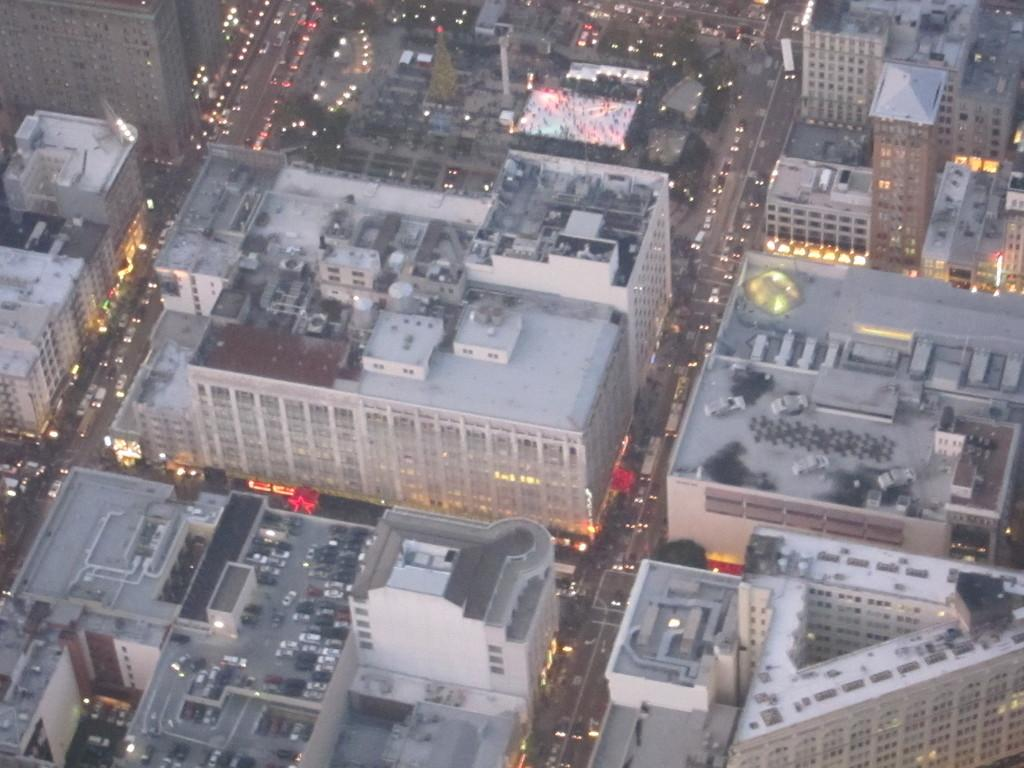What type of scene is shown in the image? The image depicts a view of a city. What structures can be seen in the image? There are buildings in the image. What can be observed illuminating the scene in the image? There are lights visible in the image. What type of transportation is present in the image? There are vehicles in the image. How many stamps are on the buildings in the image? There are no stamps visible on the buildings in the image. What type of clothing are the girls wearing in the image? There are no girls present in the image. 